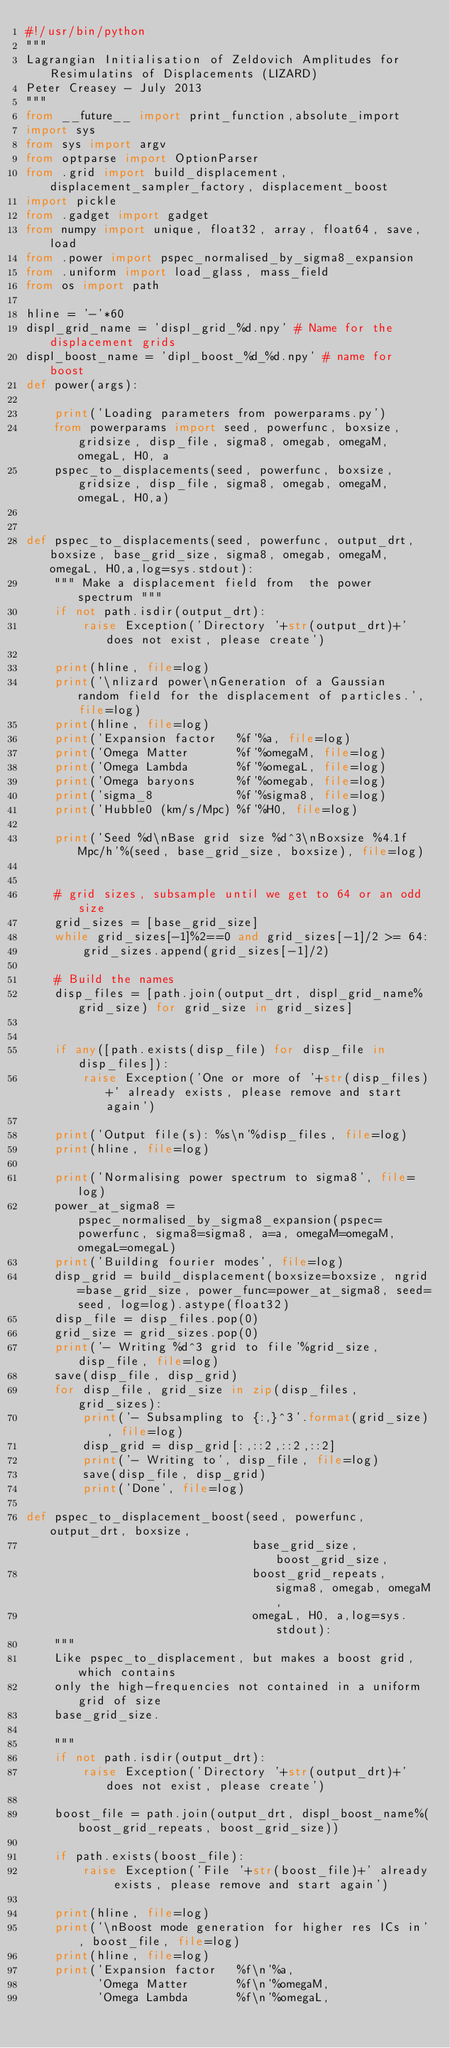Convert code to text. <code><loc_0><loc_0><loc_500><loc_500><_Python_>#!/usr/bin/python
""" 
Lagrangian Initialisation of Zeldovich Amplitudes for Resimulatins of Displacements (LIZARD)
Peter Creasey - July 2013
"""
from __future__ import print_function,absolute_import
import sys
from sys import argv
from optparse import OptionParser
from .grid import build_displacement, displacement_sampler_factory, displacement_boost
import pickle
from .gadget import gadget
from numpy import unique, float32, array, float64, save, load
from .power import pspec_normalised_by_sigma8_expansion
from .uniform import load_glass, mass_field
from os import path

hline = '-'*60
displ_grid_name = 'displ_grid_%d.npy' # Name for the displacement grids
displ_boost_name = 'dipl_boost_%d_%d.npy' # name for boost
def power(args):

    print('Loading parameters from powerparams.py')
    from powerparams import seed, powerfunc, boxsize, gridsize, disp_file, sigma8, omegab, omegaM, omegaL, H0, a
    pspec_to_displacements(seed, powerfunc, boxsize, gridsize, disp_file, sigma8, omegab, omegaM, omegaL, H0,a)


def pspec_to_displacements(seed, powerfunc, output_drt, boxsize, base_grid_size, sigma8, omegab, omegaM, omegaL, H0,a,log=sys.stdout):
    """ Make a displacement field from  the power spectrum """
    if not path.isdir(output_drt):
        raise Exception('Directory '+str(output_drt)+' does not exist, please create')

    print(hline, file=log)
    print('\nlizard power\nGeneration of a Gaussian random field for the displacement of particles.', file=log)
    print(hline, file=log)
    print('Expansion factor   %f'%a, file=log)
    print('Omega Matter       %f'%omegaM, file=log)
    print('Omega Lambda       %f'%omegaL, file=log)
    print('Omega baryons      %f'%omegab, file=log)
    print('sigma_8            %f'%sigma8, file=log)
    print('Hubble0 (km/s/Mpc) %f'%H0, file=log)

    print('Seed %d\nBase grid size %d^3\nBoxsize %4.1f Mpc/h'%(seed, base_grid_size, boxsize), file=log)


    # grid sizes, subsample until we get to 64 or an odd size
    grid_sizes = [base_grid_size]
    while grid_sizes[-1]%2==0 and grid_sizes[-1]/2 >= 64: 
        grid_sizes.append(grid_sizes[-1]/2) 
        
    # Build the names
    disp_files = [path.join(output_drt, displ_grid_name%grid_size) for grid_size in grid_sizes]


    if any([path.exists(disp_file) for disp_file in disp_files]):
        raise Exception('One or more of '+str(disp_files)+' already exists, please remove and start again')        

    print('Output file(s): %s\n'%disp_files, file=log)
    print(hline, file=log)

    print('Normalising power spectrum to sigma8', file=log)
    power_at_sigma8 = pspec_normalised_by_sigma8_expansion(pspec=powerfunc, sigma8=sigma8, a=a, omegaM=omegaM, omegaL=omegaL)
    print('Building fourier modes', file=log)
    disp_grid = build_displacement(boxsize=boxsize, ngrid=base_grid_size, power_func=power_at_sigma8, seed=seed, log=log).astype(float32)
    disp_file = disp_files.pop(0)
    grid_size = grid_sizes.pop(0)
    print('- Writing %d^3 grid to file'%grid_size, disp_file, file=log)
    save(disp_file, disp_grid)
    for disp_file, grid_size in zip(disp_files, grid_sizes):
        print('- Subsampling to {:,}^3'.format(grid_size), file=log)
        disp_grid = disp_grid[:,::2,::2,::2] 
        print('- Writing to', disp_file, file=log)
        save(disp_file, disp_grid)
        print('Done', file=log)

def pspec_to_displacement_boost(seed, powerfunc, output_drt, boxsize, 
                                base_grid_size, boost_grid_size, 
                                boost_grid_repeats, sigma8, omegab, omegaM, 
                                omegaL, H0, a,log=sys.stdout):                             
    """ 
    Like pspec_to_displacement, but makes a boost grid, which contains
    only the high-frequencies not contained in a uniform grid of size 
    base_grid_size.

    """
    if not path.isdir(output_drt):
        raise Exception('Directory '+str(output_drt)+' does not exist, please create')

    boost_file = path.join(output_drt, displ_boost_name%(boost_grid_repeats, boost_grid_size))

    if path.exists(boost_file):
        raise Exception('File '+str(boost_file)+' already exists, please remove and start again')        
    
    print(hline, file=log)
    print('\nBoost mode generation for higher res ICs in', boost_file, file=log)
    print(hline, file=log)
    print('Expansion factor   %f\n'%a, 
          'Omega Matter       %f\n'%omegaM, 
          'Omega Lambda       %f\n'%omegaL, </code> 